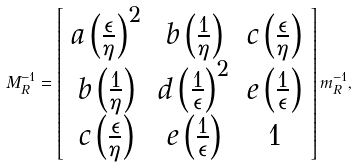Convert formula to latex. <formula><loc_0><loc_0><loc_500><loc_500>M ^ { - 1 } _ { R } = \left [ \begin{array} { c c c } a \left ( \frac { \epsilon } { \eta } \right ) ^ { 2 } & b \left ( \frac { 1 } { \eta } \right ) & c \left ( \frac { \epsilon } { \eta } \right ) \\ b \left ( \frac { 1 } { \eta } \right ) & d \left ( \frac { 1 } { \epsilon } \right ) ^ { 2 } & e \left ( \frac { 1 } { \epsilon } \right ) \\ c \left ( \frac { \epsilon } { \eta } \right ) & e \left ( \frac { 1 } { \epsilon } \right ) & 1 \end{array} \right ] m ^ { - 1 } _ { R } ,</formula> 